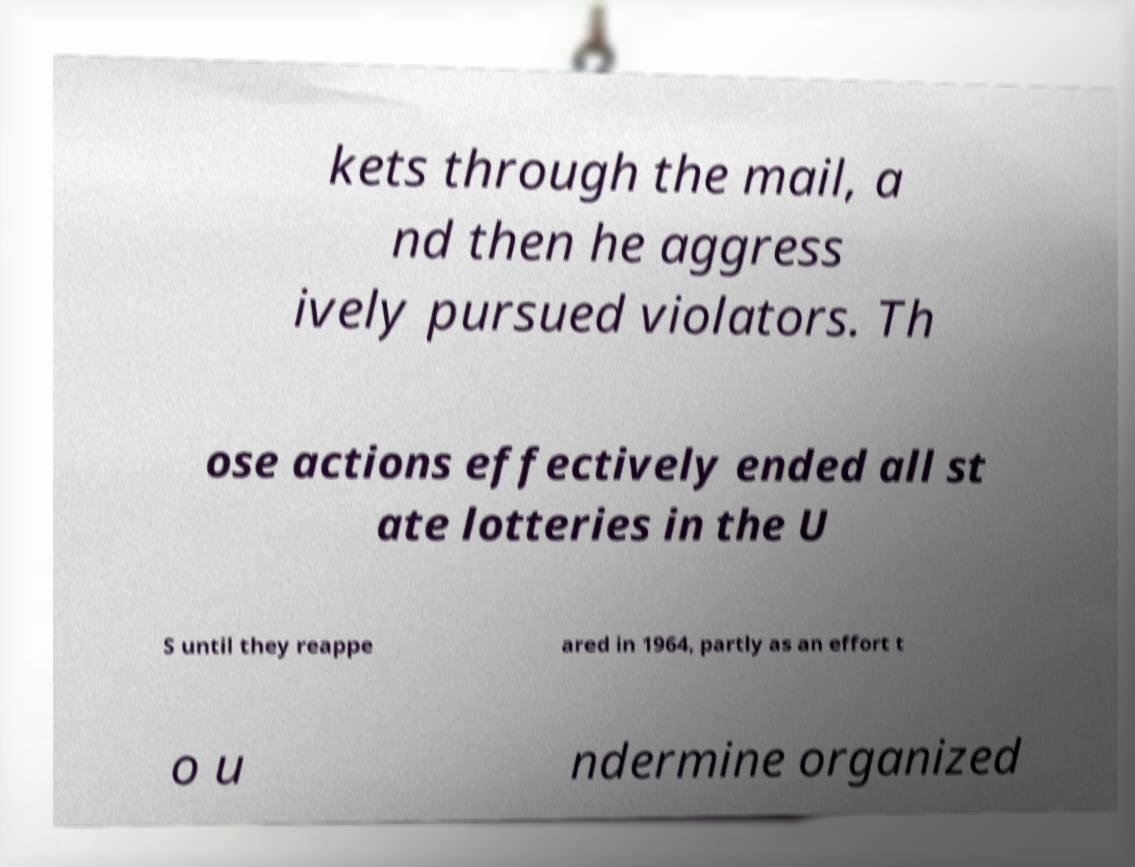Could you assist in decoding the text presented in this image and type it out clearly? kets through the mail, a nd then he aggress ively pursued violators. Th ose actions effectively ended all st ate lotteries in the U S until they reappe ared in 1964, partly as an effort t o u ndermine organized 